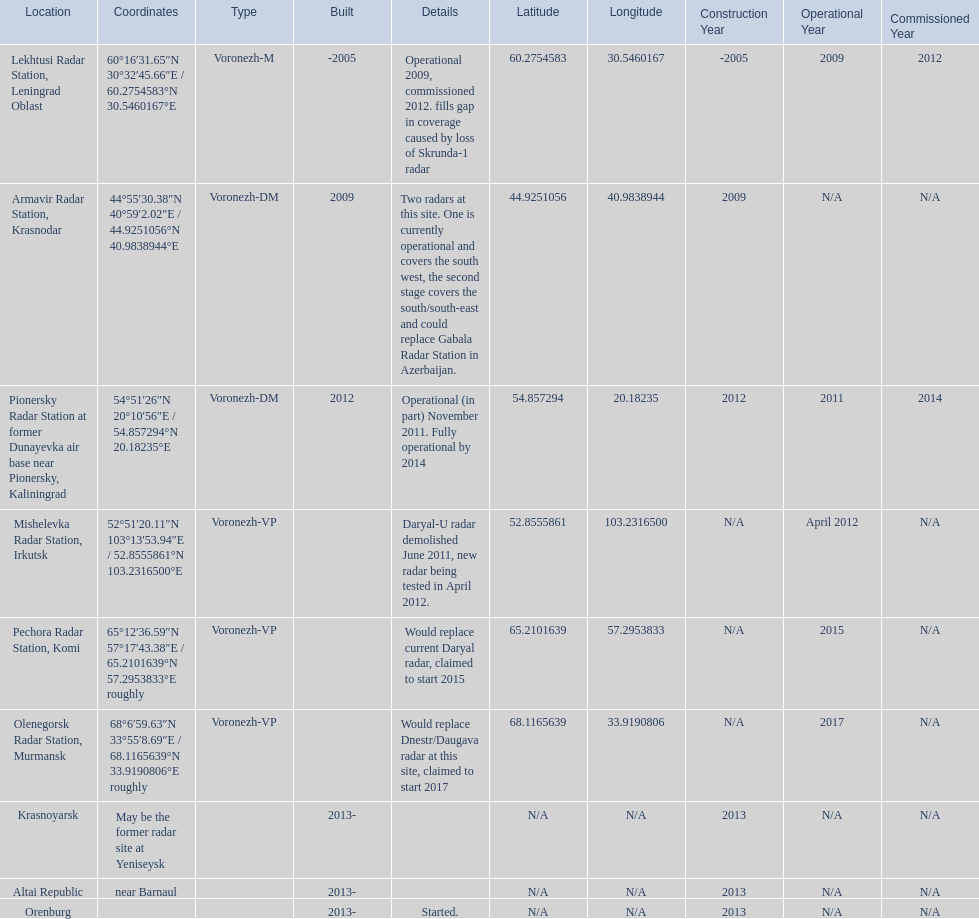Which voronezh radar has already started? Orenburg. Which radar would replace dnestr/daugava? Olenegorsk Radar Station, Murmansk. Which radar started in 2015? Pechora Radar Station, Komi. 